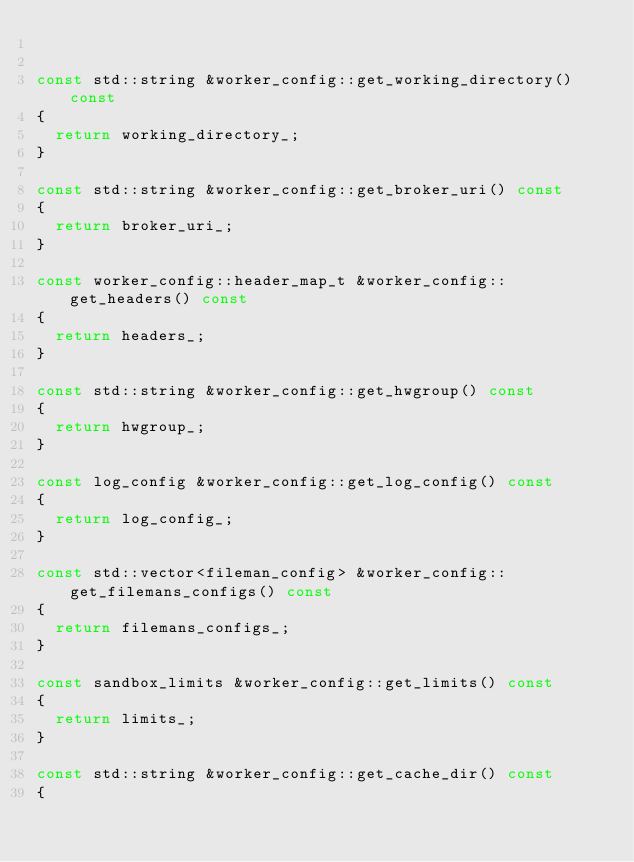Convert code to text. <code><loc_0><loc_0><loc_500><loc_500><_C++_>

const std::string &worker_config::get_working_directory() const
{
	return working_directory_;
}

const std::string &worker_config::get_broker_uri() const
{
	return broker_uri_;
}

const worker_config::header_map_t &worker_config::get_headers() const
{
	return headers_;
}

const std::string &worker_config::get_hwgroup() const
{
	return hwgroup_;
}

const log_config &worker_config::get_log_config() const
{
	return log_config_;
}

const std::vector<fileman_config> &worker_config::get_filemans_configs() const
{
	return filemans_configs_;
}

const sandbox_limits &worker_config::get_limits() const
{
	return limits_;
}

const std::string &worker_config::get_cache_dir() const
{</code> 